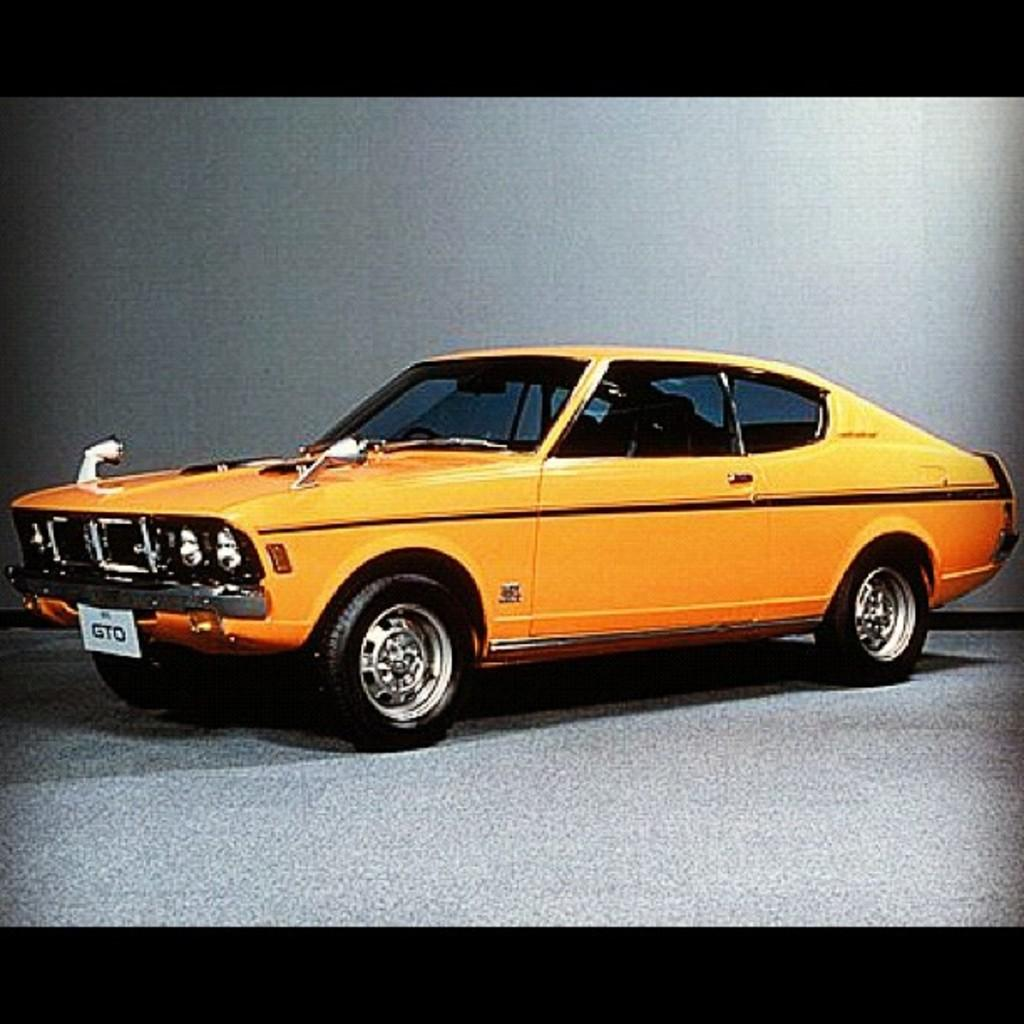What feature surrounds the main content of the image? The image has borders. What mode of transportation can be seen in the image? There is a car in the image. What surface is at the bottom of the image? There is a floor at the bottom of the image. What type of structure is visible in the background of the image? There is a wall visible in the background of the image. What type of flag is being waved by the friend in the image? There is no friend or flag present in the image. 